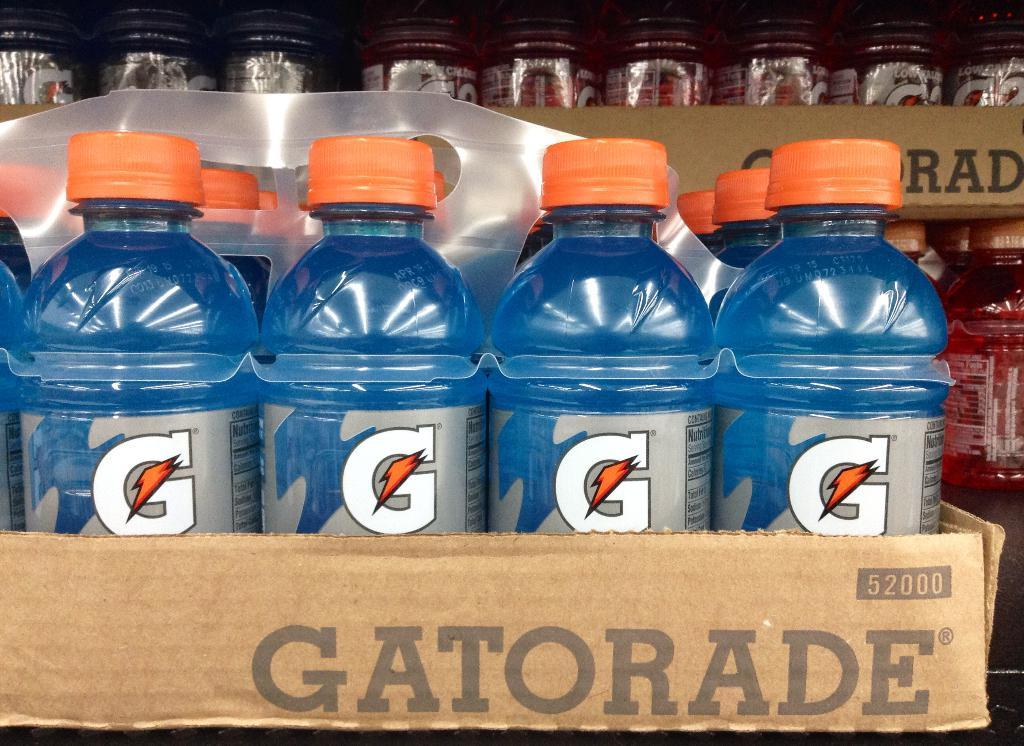<image>
Give a short and clear explanation of the subsequent image. A collection of Gatorade bottles in a box that says Gatorade on it. 